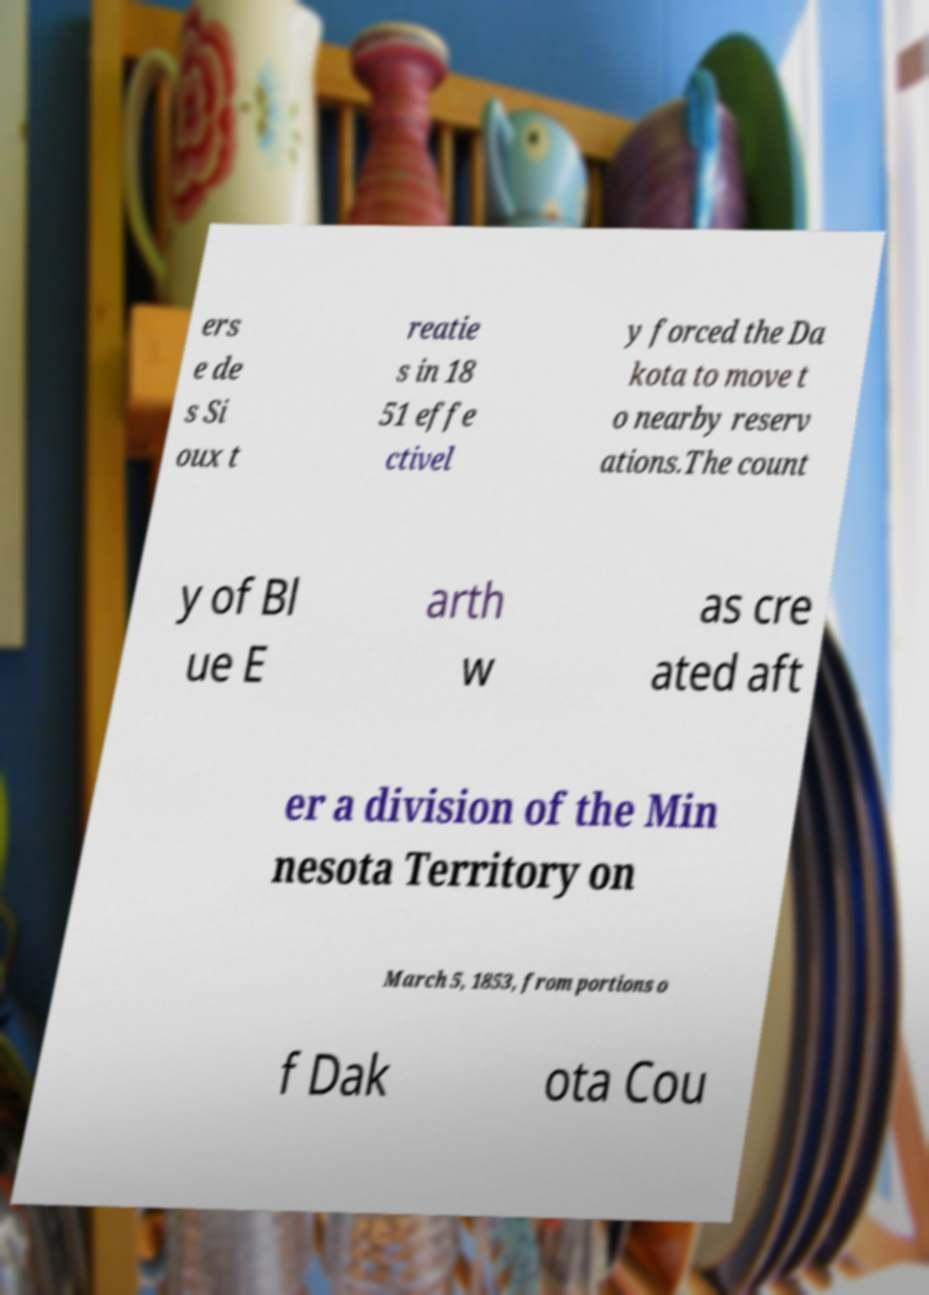Could you extract and type out the text from this image? ers e de s Si oux t reatie s in 18 51 effe ctivel y forced the Da kota to move t o nearby reserv ations.The count y of Bl ue E arth w as cre ated aft er a division of the Min nesota Territory on March 5, 1853, from portions o f Dak ota Cou 